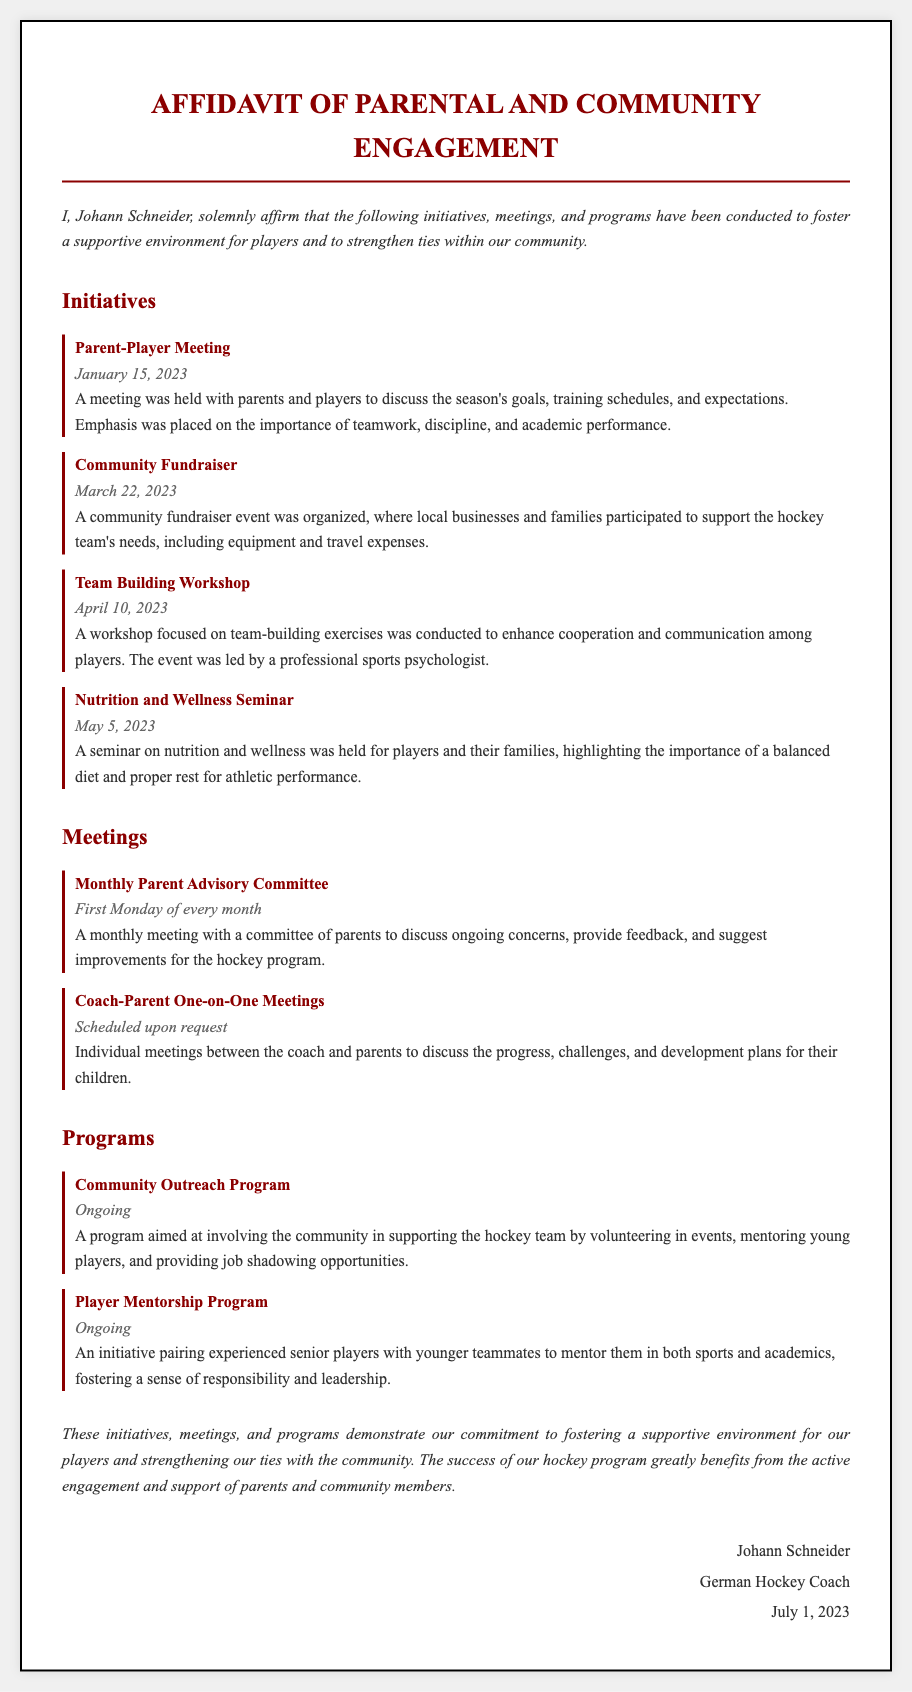What is the name of the coach? The affidavit states the name of the coach at the end of the document.
Answer: Johann Schneider When was the Parent-Player Meeting held? The date for the Parent-Player Meeting is provided in the initiatives section.
Answer: January 15, 2023 What type of seminar was held on May 5, 2023? The document specifies the type of seminar conducted on that date.
Answer: Nutrition and Wellness Seminar How often does the Monthly Parent Advisory Committee meet? The frequency of the meetings is stated in the meetings section of the document.
Answer: First Monday of every month What is the main goal of the Player Mentorship Program? The goal of the program is discussed in the programs section and relates to mentorship and development.
Answer: Foster responsibility and leadership Who led the Team Building Workshop? The document mentions who was responsible for leading the workshop.
Answer: A professional sports psychologist What is a key focus of the Community Outreach Program? The focus of this program is described in the programs section of the document.
Answer: Involving the community What is emphasized during the Parent-Player Meeting? The affidavit specifies key topics discussed during the meeting.
Answer: Teamwork, discipline, and academic performance 